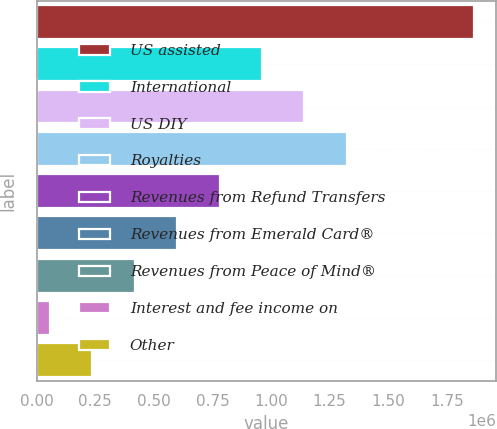<chart> <loc_0><loc_0><loc_500><loc_500><bar_chart><fcel>US assisted<fcel>International<fcel>US DIY<fcel>Royalties<fcel>Revenues from Refund Transfers<fcel>Revenues from Emerald Card®<fcel>Revenues from Peace of Mind®<fcel>Interest and fee income on<fcel>Other<nl><fcel>1.86544e+06<fcel>961320<fcel>1.14214e+06<fcel>1.32297e+06<fcel>780496<fcel>599673<fcel>418849<fcel>57202<fcel>238026<nl></chart> 